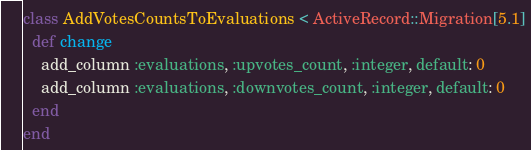<code> <loc_0><loc_0><loc_500><loc_500><_Ruby_>class AddVotesCountsToEvaluations < ActiveRecord::Migration[5.1]
  def change
    add_column :evaluations, :upvotes_count, :integer, default: 0
    add_column :evaluations, :downvotes_count, :integer, default: 0
  end
end
</code> 